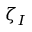<formula> <loc_0><loc_0><loc_500><loc_500>\zeta _ { I }</formula> 